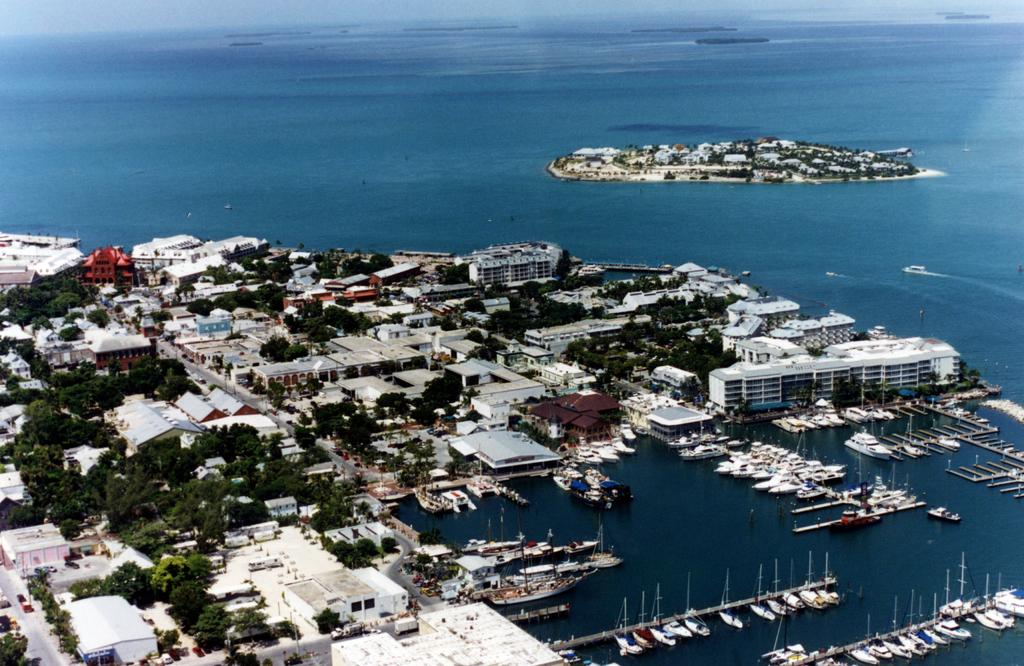What type of location is depicted in the image? The image shows a view of a city. What structures can be seen in the city? There are buildings in the image. Are there any natural elements present in the image? Yes, there are trees in the image. What can be seen on the right side of the image? There are boats and ships on the water on the right side of the image. Is there any landmass visible in the water? Yes, there is an island visible in the image. What type of lamp is hanging from the trees in the image? There are no lamps hanging from the trees in the image; only buildings, trees, boats, ships, and an island are present. Can you see anyone biting into an apple in the image? There is no apple or anyone biting into it in the image. 